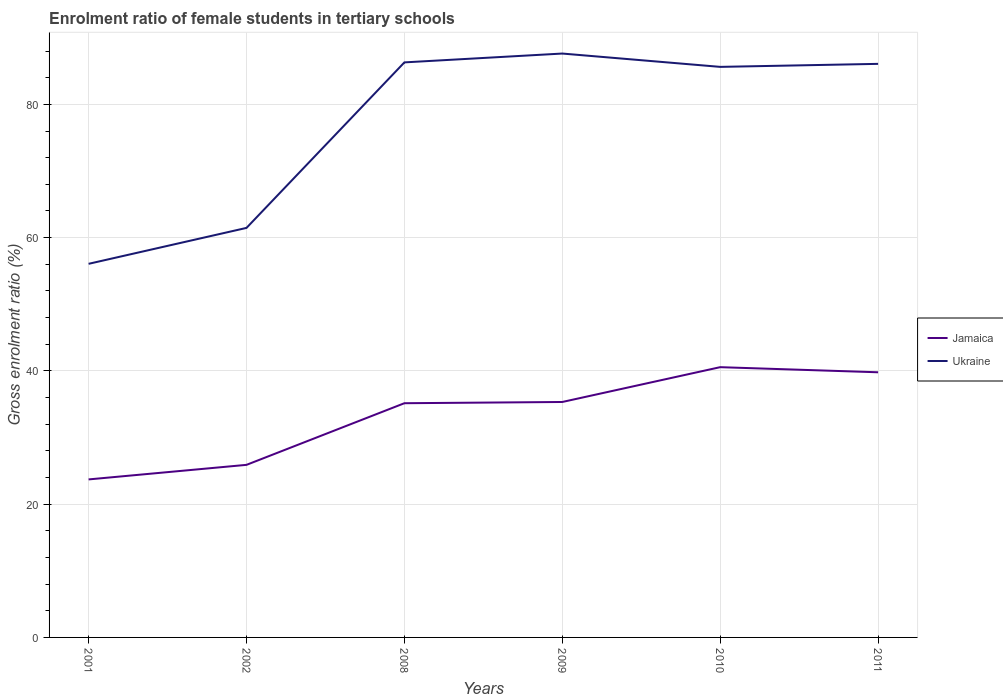How many different coloured lines are there?
Make the answer very short. 2. Is the number of lines equal to the number of legend labels?
Your response must be concise. Yes. Across all years, what is the maximum enrolment ratio of female students in tertiary schools in Ukraine?
Your answer should be very brief. 56.07. In which year was the enrolment ratio of female students in tertiary schools in Ukraine maximum?
Keep it short and to the point. 2001. What is the total enrolment ratio of female students in tertiary schools in Jamaica in the graph?
Offer a terse response. -16.08. What is the difference between the highest and the second highest enrolment ratio of female students in tertiary schools in Jamaica?
Offer a terse response. 16.85. Where does the legend appear in the graph?
Ensure brevity in your answer.  Center right. How many legend labels are there?
Keep it short and to the point. 2. What is the title of the graph?
Provide a short and direct response. Enrolment ratio of female students in tertiary schools. Does "Mauritius" appear as one of the legend labels in the graph?
Your answer should be compact. No. What is the label or title of the X-axis?
Provide a short and direct response. Years. What is the Gross enrolment ratio (%) in Jamaica in 2001?
Give a very brief answer. 23.71. What is the Gross enrolment ratio (%) of Ukraine in 2001?
Your answer should be very brief. 56.07. What is the Gross enrolment ratio (%) in Jamaica in 2002?
Ensure brevity in your answer.  25.9. What is the Gross enrolment ratio (%) in Ukraine in 2002?
Offer a terse response. 61.46. What is the Gross enrolment ratio (%) of Jamaica in 2008?
Your answer should be compact. 35.15. What is the Gross enrolment ratio (%) of Ukraine in 2008?
Your response must be concise. 86.3. What is the Gross enrolment ratio (%) of Jamaica in 2009?
Provide a succinct answer. 35.33. What is the Gross enrolment ratio (%) in Ukraine in 2009?
Your answer should be very brief. 87.63. What is the Gross enrolment ratio (%) in Jamaica in 2010?
Offer a very short reply. 40.56. What is the Gross enrolment ratio (%) of Ukraine in 2010?
Give a very brief answer. 85.63. What is the Gross enrolment ratio (%) of Jamaica in 2011?
Make the answer very short. 39.79. What is the Gross enrolment ratio (%) in Ukraine in 2011?
Ensure brevity in your answer.  86.08. Across all years, what is the maximum Gross enrolment ratio (%) of Jamaica?
Make the answer very short. 40.56. Across all years, what is the maximum Gross enrolment ratio (%) of Ukraine?
Offer a terse response. 87.63. Across all years, what is the minimum Gross enrolment ratio (%) of Jamaica?
Your answer should be very brief. 23.71. Across all years, what is the minimum Gross enrolment ratio (%) of Ukraine?
Your answer should be compact. 56.07. What is the total Gross enrolment ratio (%) of Jamaica in the graph?
Provide a succinct answer. 200.45. What is the total Gross enrolment ratio (%) of Ukraine in the graph?
Your answer should be very brief. 463.16. What is the difference between the Gross enrolment ratio (%) of Jamaica in 2001 and that in 2002?
Your answer should be very brief. -2.18. What is the difference between the Gross enrolment ratio (%) of Ukraine in 2001 and that in 2002?
Ensure brevity in your answer.  -5.39. What is the difference between the Gross enrolment ratio (%) of Jamaica in 2001 and that in 2008?
Make the answer very short. -11.44. What is the difference between the Gross enrolment ratio (%) of Ukraine in 2001 and that in 2008?
Provide a succinct answer. -30.23. What is the difference between the Gross enrolment ratio (%) of Jamaica in 2001 and that in 2009?
Offer a terse response. -11.62. What is the difference between the Gross enrolment ratio (%) of Ukraine in 2001 and that in 2009?
Ensure brevity in your answer.  -31.56. What is the difference between the Gross enrolment ratio (%) of Jamaica in 2001 and that in 2010?
Provide a short and direct response. -16.85. What is the difference between the Gross enrolment ratio (%) of Ukraine in 2001 and that in 2010?
Offer a very short reply. -29.56. What is the difference between the Gross enrolment ratio (%) of Jamaica in 2001 and that in 2011?
Offer a very short reply. -16.08. What is the difference between the Gross enrolment ratio (%) of Ukraine in 2001 and that in 2011?
Your answer should be compact. -30.01. What is the difference between the Gross enrolment ratio (%) of Jamaica in 2002 and that in 2008?
Give a very brief answer. -9.25. What is the difference between the Gross enrolment ratio (%) in Ukraine in 2002 and that in 2008?
Ensure brevity in your answer.  -24.84. What is the difference between the Gross enrolment ratio (%) in Jamaica in 2002 and that in 2009?
Offer a very short reply. -9.44. What is the difference between the Gross enrolment ratio (%) in Ukraine in 2002 and that in 2009?
Keep it short and to the point. -26.17. What is the difference between the Gross enrolment ratio (%) of Jamaica in 2002 and that in 2010?
Give a very brief answer. -14.66. What is the difference between the Gross enrolment ratio (%) in Ukraine in 2002 and that in 2010?
Offer a very short reply. -24.16. What is the difference between the Gross enrolment ratio (%) of Jamaica in 2002 and that in 2011?
Offer a terse response. -13.89. What is the difference between the Gross enrolment ratio (%) in Ukraine in 2002 and that in 2011?
Your response must be concise. -24.62. What is the difference between the Gross enrolment ratio (%) in Jamaica in 2008 and that in 2009?
Offer a very short reply. -0.19. What is the difference between the Gross enrolment ratio (%) in Ukraine in 2008 and that in 2009?
Provide a short and direct response. -1.33. What is the difference between the Gross enrolment ratio (%) in Jamaica in 2008 and that in 2010?
Make the answer very short. -5.41. What is the difference between the Gross enrolment ratio (%) of Ukraine in 2008 and that in 2010?
Ensure brevity in your answer.  0.67. What is the difference between the Gross enrolment ratio (%) of Jamaica in 2008 and that in 2011?
Offer a terse response. -4.64. What is the difference between the Gross enrolment ratio (%) of Ukraine in 2008 and that in 2011?
Keep it short and to the point. 0.22. What is the difference between the Gross enrolment ratio (%) in Jamaica in 2009 and that in 2010?
Offer a very short reply. -5.22. What is the difference between the Gross enrolment ratio (%) in Ukraine in 2009 and that in 2010?
Your response must be concise. 2. What is the difference between the Gross enrolment ratio (%) of Jamaica in 2009 and that in 2011?
Offer a terse response. -4.46. What is the difference between the Gross enrolment ratio (%) of Ukraine in 2009 and that in 2011?
Your answer should be very brief. 1.55. What is the difference between the Gross enrolment ratio (%) of Jamaica in 2010 and that in 2011?
Provide a succinct answer. 0.77. What is the difference between the Gross enrolment ratio (%) of Ukraine in 2010 and that in 2011?
Offer a very short reply. -0.45. What is the difference between the Gross enrolment ratio (%) of Jamaica in 2001 and the Gross enrolment ratio (%) of Ukraine in 2002?
Your answer should be compact. -37.75. What is the difference between the Gross enrolment ratio (%) of Jamaica in 2001 and the Gross enrolment ratio (%) of Ukraine in 2008?
Provide a short and direct response. -62.59. What is the difference between the Gross enrolment ratio (%) in Jamaica in 2001 and the Gross enrolment ratio (%) in Ukraine in 2009?
Provide a succinct answer. -63.91. What is the difference between the Gross enrolment ratio (%) in Jamaica in 2001 and the Gross enrolment ratio (%) in Ukraine in 2010?
Provide a short and direct response. -61.91. What is the difference between the Gross enrolment ratio (%) in Jamaica in 2001 and the Gross enrolment ratio (%) in Ukraine in 2011?
Offer a very short reply. -62.36. What is the difference between the Gross enrolment ratio (%) in Jamaica in 2002 and the Gross enrolment ratio (%) in Ukraine in 2008?
Provide a succinct answer. -60.4. What is the difference between the Gross enrolment ratio (%) of Jamaica in 2002 and the Gross enrolment ratio (%) of Ukraine in 2009?
Offer a terse response. -61.73. What is the difference between the Gross enrolment ratio (%) in Jamaica in 2002 and the Gross enrolment ratio (%) in Ukraine in 2010?
Your answer should be compact. -59.73. What is the difference between the Gross enrolment ratio (%) of Jamaica in 2002 and the Gross enrolment ratio (%) of Ukraine in 2011?
Offer a very short reply. -60.18. What is the difference between the Gross enrolment ratio (%) of Jamaica in 2008 and the Gross enrolment ratio (%) of Ukraine in 2009?
Offer a very short reply. -52.48. What is the difference between the Gross enrolment ratio (%) in Jamaica in 2008 and the Gross enrolment ratio (%) in Ukraine in 2010?
Your answer should be very brief. -50.48. What is the difference between the Gross enrolment ratio (%) in Jamaica in 2008 and the Gross enrolment ratio (%) in Ukraine in 2011?
Provide a short and direct response. -50.93. What is the difference between the Gross enrolment ratio (%) in Jamaica in 2009 and the Gross enrolment ratio (%) in Ukraine in 2010?
Provide a short and direct response. -50.29. What is the difference between the Gross enrolment ratio (%) of Jamaica in 2009 and the Gross enrolment ratio (%) of Ukraine in 2011?
Your answer should be very brief. -50.74. What is the difference between the Gross enrolment ratio (%) of Jamaica in 2010 and the Gross enrolment ratio (%) of Ukraine in 2011?
Make the answer very short. -45.52. What is the average Gross enrolment ratio (%) of Jamaica per year?
Your answer should be compact. 33.41. What is the average Gross enrolment ratio (%) of Ukraine per year?
Offer a terse response. 77.19. In the year 2001, what is the difference between the Gross enrolment ratio (%) in Jamaica and Gross enrolment ratio (%) in Ukraine?
Provide a short and direct response. -32.36. In the year 2002, what is the difference between the Gross enrolment ratio (%) in Jamaica and Gross enrolment ratio (%) in Ukraine?
Keep it short and to the point. -35.56. In the year 2008, what is the difference between the Gross enrolment ratio (%) of Jamaica and Gross enrolment ratio (%) of Ukraine?
Give a very brief answer. -51.15. In the year 2009, what is the difference between the Gross enrolment ratio (%) of Jamaica and Gross enrolment ratio (%) of Ukraine?
Keep it short and to the point. -52.29. In the year 2010, what is the difference between the Gross enrolment ratio (%) of Jamaica and Gross enrolment ratio (%) of Ukraine?
Make the answer very short. -45.07. In the year 2011, what is the difference between the Gross enrolment ratio (%) in Jamaica and Gross enrolment ratio (%) in Ukraine?
Your answer should be very brief. -46.29. What is the ratio of the Gross enrolment ratio (%) of Jamaica in 2001 to that in 2002?
Offer a terse response. 0.92. What is the ratio of the Gross enrolment ratio (%) in Ukraine in 2001 to that in 2002?
Ensure brevity in your answer.  0.91. What is the ratio of the Gross enrolment ratio (%) in Jamaica in 2001 to that in 2008?
Keep it short and to the point. 0.67. What is the ratio of the Gross enrolment ratio (%) of Ukraine in 2001 to that in 2008?
Provide a succinct answer. 0.65. What is the ratio of the Gross enrolment ratio (%) in Jamaica in 2001 to that in 2009?
Ensure brevity in your answer.  0.67. What is the ratio of the Gross enrolment ratio (%) of Ukraine in 2001 to that in 2009?
Provide a short and direct response. 0.64. What is the ratio of the Gross enrolment ratio (%) of Jamaica in 2001 to that in 2010?
Your answer should be very brief. 0.58. What is the ratio of the Gross enrolment ratio (%) in Ukraine in 2001 to that in 2010?
Offer a terse response. 0.65. What is the ratio of the Gross enrolment ratio (%) in Jamaica in 2001 to that in 2011?
Offer a very short reply. 0.6. What is the ratio of the Gross enrolment ratio (%) of Ukraine in 2001 to that in 2011?
Provide a succinct answer. 0.65. What is the ratio of the Gross enrolment ratio (%) in Jamaica in 2002 to that in 2008?
Provide a short and direct response. 0.74. What is the ratio of the Gross enrolment ratio (%) in Ukraine in 2002 to that in 2008?
Your answer should be very brief. 0.71. What is the ratio of the Gross enrolment ratio (%) of Jamaica in 2002 to that in 2009?
Provide a short and direct response. 0.73. What is the ratio of the Gross enrolment ratio (%) in Ukraine in 2002 to that in 2009?
Your response must be concise. 0.7. What is the ratio of the Gross enrolment ratio (%) of Jamaica in 2002 to that in 2010?
Keep it short and to the point. 0.64. What is the ratio of the Gross enrolment ratio (%) of Ukraine in 2002 to that in 2010?
Your answer should be compact. 0.72. What is the ratio of the Gross enrolment ratio (%) in Jamaica in 2002 to that in 2011?
Provide a short and direct response. 0.65. What is the ratio of the Gross enrolment ratio (%) of Ukraine in 2002 to that in 2011?
Make the answer very short. 0.71. What is the ratio of the Gross enrolment ratio (%) of Ukraine in 2008 to that in 2009?
Offer a terse response. 0.98. What is the ratio of the Gross enrolment ratio (%) in Jamaica in 2008 to that in 2010?
Offer a very short reply. 0.87. What is the ratio of the Gross enrolment ratio (%) of Ukraine in 2008 to that in 2010?
Offer a very short reply. 1.01. What is the ratio of the Gross enrolment ratio (%) of Jamaica in 2008 to that in 2011?
Your answer should be very brief. 0.88. What is the ratio of the Gross enrolment ratio (%) of Jamaica in 2009 to that in 2010?
Offer a terse response. 0.87. What is the ratio of the Gross enrolment ratio (%) of Ukraine in 2009 to that in 2010?
Ensure brevity in your answer.  1.02. What is the ratio of the Gross enrolment ratio (%) of Jamaica in 2009 to that in 2011?
Offer a terse response. 0.89. What is the ratio of the Gross enrolment ratio (%) in Jamaica in 2010 to that in 2011?
Provide a succinct answer. 1.02. What is the difference between the highest and the second highest Gross enrolment ratio (%) of Jamaica?
Make the answer very short. 0.77. What is the difference between the highest and the second highest Gross enrolment ratio (%) in Ukraine?
Your answer should be compact. 1.33. What is the difference between the highest and the lowest Gross enrolment ratio (%) of Jamaica?
Your answer should be very brief. 16.85. What is the difference between the highest and the lowest Gross enrolment ratio (%) of Ukraine?
Keep it short and to the point. 31.56. 